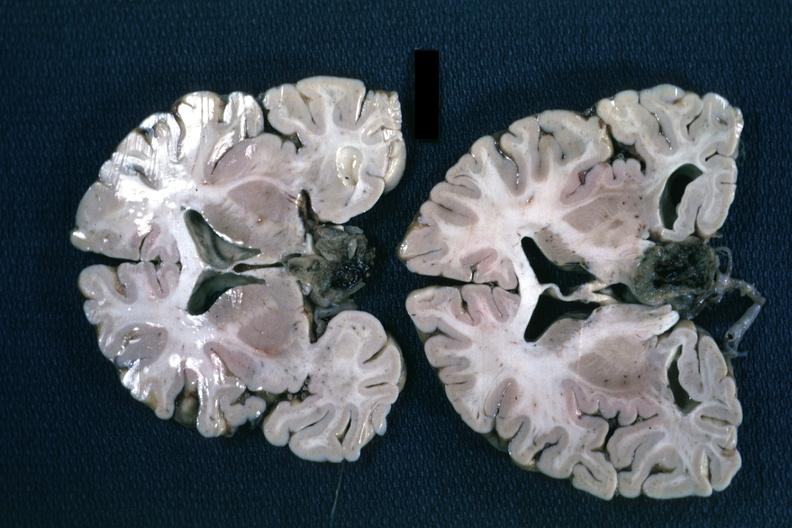what is present?
Answer the question using a single word or phrase. Pituitary 